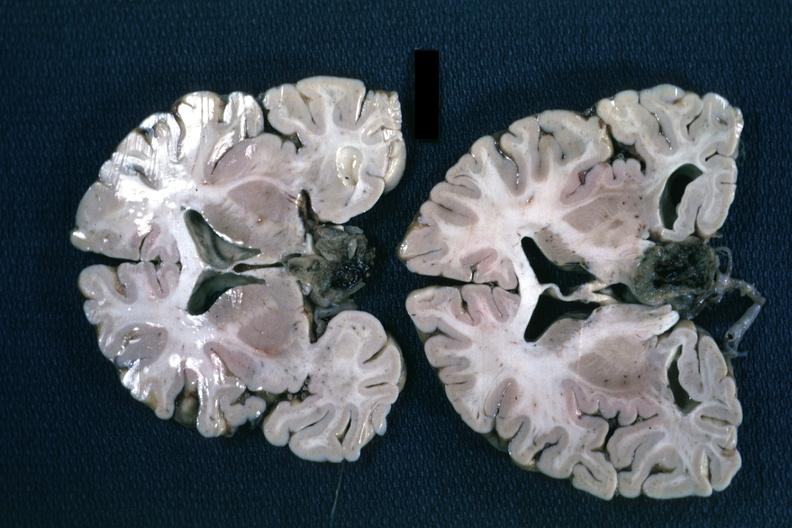what is present?
Answer the question using a single word or phrase. Pituitary 